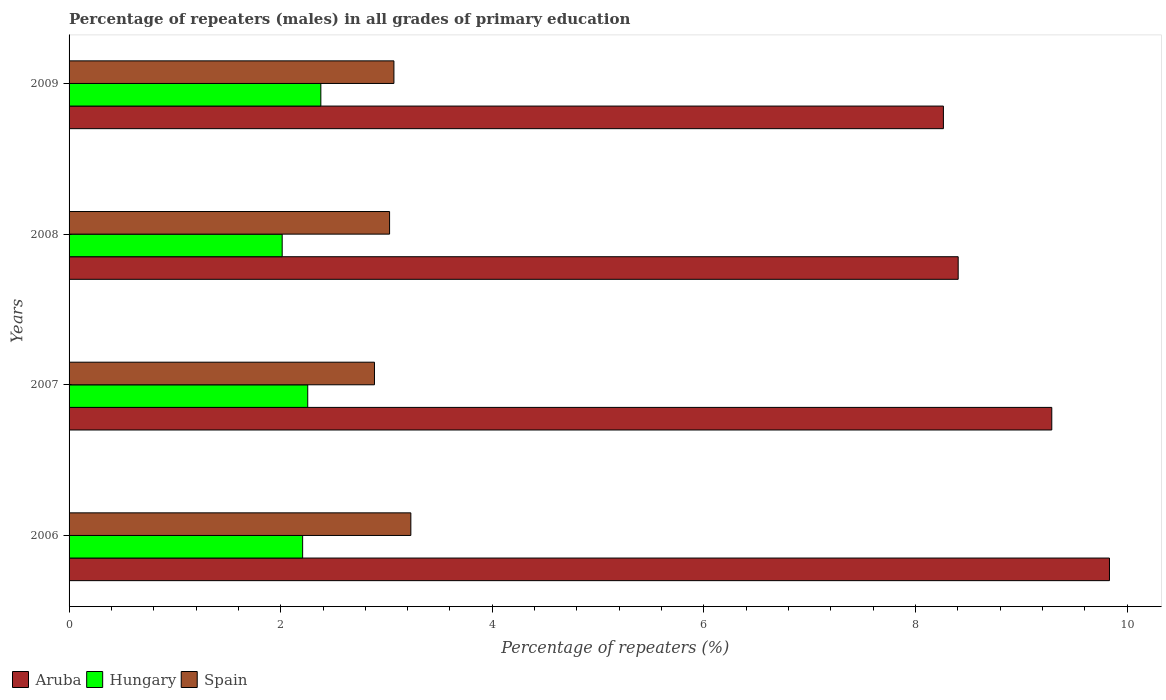How many different coloured bars are there?
Your answer should be compact. 3. How many groups of bars are there?
Make the answer very short. 4. Are the number of bars on each tick of the Y-axis equal?
Make the answer very short. Yes. How many bars are there on the 3rd tick from the top?
Ensure brevity in your answer.  3. In how many cases, is the number of bars for a given year not equal to the number of legend labels?
Offer a very short reply. 0. What is the percentage of repeaters (males) in Aruba in 2006?
Ensure brevity in your answer.  9.83. Across all years, what is the maximum percentage of repeaters (males) in Aruba?
Ensure brevity in your answer.  9.83. Across all years, what is the minimum percentage of repeaters (males) in Hungary?
Provide a succinct answer. 2.01. In which year was the percentage of repeaters (males) in Aruba minimum?
Ensure brevity in your answer.  2009. What is the total percentage of repeaters (males) in Aruba in the graph?
Give a very brief answer. 35.79. What is the difference between the percentage of repeaters (males) in Spain in 2008 and that in 2009?
Make the answer very short. -0.04. What is the difference between the percentage of repeaters (males) in Spain in 2009 and the percentage of repeaters (males) in Hungary in 2008?
Your response must be concise. 1.06. What is the average percentage of repeaters (males) in Hungary per year?
Provide a succinct answer. 2.21. In the year 2008, what is the difference between the percentage of repeaters (males) in Aruba and percentage of repeaters (males) in Hungary?
Give a very brief answer. 6.39. What is the ratio of the percentage of repeaters (males) in Hungary in 2008 to that in 2009?
Your response must be concise. 0.85. Is the percentage of repeaters (males) in Spain in 2006 less than that in 2008?
Offer a very short reply. No. Is the difference between the percentage of repeaters (males) in Aruba in 2008 and 2009 greater than the difference between the percentage of repeaters (males) in Hungary in 2008 and 2009?
Give a very brief answer. Yes. What is the difference between the highest and the second highest percentage of repeaters (males) in Aruba?
Provide a short and direct response. 0.55. What is the difference between the highest and the lowest percentage of repeaters (males) in Hungary?
Provide a succinct answer. 0.37. What does the 2nd bar from the top in 2008 represents?
Offer a very short reply. Hungary. What does the 3rd bar from the bottom in 2009 represents?
Your answer should be very brief. Spain. Is it the case that in every year, the sum of the percentage of repeaters (males) in Aruba and percentage of repeaters (males) in Hungary is greater than the percentage of repeaters (males) in Spain?
Offer a terse response. Yes. How many years are there in the graph?
Provide a short and direct response. 4. Does the graph contain any zero values?
Ensure brevity in your answer.  No. How many legend labels are there?
Provide a short and direct response. 3. What is the title of the graph?
Your answer should be compact. Percentage of repeaters (males) in all grades of primary education. Does "India" appear as one of the legend labels in the graph?
Keep it short and to the point. No. What is the label or title of the X-axis?
Your response must be concise. Percentage of repeaters (%). What is the label or title of the Y-axis?
Offer a very short reply. Years. What is the Percentage of repeaters (%) of Aruba in 2006?
Make the answer very short. 9.83. What is the Percentage of repeaters (%) of Hungary in 2006?
Offer a very short reply. 2.21. What is the Percentage of repeaters (%) in Spain in 2006?
Ensure brevity in your answer.  3.23. What is the Percentage of repeaters (%) of Aruba in 2007?
Offer a very short reply. 9.29. What is the Percentage of repeaters (%) of Hungary in 2007?
Your answer should be very brief. 2.26. What is the Percentage of repeaters (%) in Spain in 2007?
Your response must be concise. 2.89. What is the Percentage of repeaters (%) in Aruba in 2008?
Offer a terse response. 8.4. What is the Percentage of repeaters (%) in Hungary in 2008?
Provide a short and direct response. 2.01. What is the Percentage of repeaters (%) of Spain in 2008?
Offer a very short reply. 3.03. What is the Percentage of repeaters (%) of Aruba in 2009?
Your answer should be compact. 8.26. What is the Percentage of repeaters (%) in Hungary in 2009?
Ensure brevity in your answer.  2.38. What is the Percentage of repeaters (%) in Spain in 2009?
Your response must be concise. 3.07. Across all years, what is the maximum Percentage of repeaters (%) of Aruba?
Make the answer very short. 9.83. Across all years, what is the maximum Percentage of repeaters (%) of Hungary?
Your answer should be very brief. 2.38. Across all years, what is the maximum Percentage of repeaters (%) in Spain?
Your answer should be compact. 3.23. Across all years, what is the minimum Percentage of repeaters (%) in Aruba?
Ensure brevity in your answer.  8.26. Across all years, what is the minimum Percentage of repeaters (%) of Hungary?
Offer a terse response. 2.01. Across all years, what is the minimum Percentage of repeaters (%) in Spain?
Keep it short and to the point. 2.89. What is the total Percentage of repeaters (%) of Aruba in the graph?
Make the answer very short. 35.79. What is the total Percentage of repeaters (%) of Hungary in the graph?
Offer a terse response. 8.86. What is the total Percentage of repeaters (%) in Spain in the graph?
Provide a short and direct response. 12.22. What is the difference between the Percentage of repeaters (%) of Aruba in 2006 and that in 2007?
Your answer should be very brief. 0.55. What is the difference between the Percentage of repeaters (%) in Hungary in 2006 and that in 2007?
Offer a terse response. -0.05. What is the difference between the Percentage of repeaters (%) of Spain in 2006 and that in 2007?
Give a very brief answer. 0.34. What is the difference between the Percentage of repeaters (%) in Aruba in 2006 and that in 2008?
Keep it short and to the point. 1.43. What is the difference between the Percentage of repeaters (%) of Hungary in 2006 and that in 2008?
Give a very brief answer. 0.19. What is the difference between the Percentage of repeaters (%) in Spain in 2006 and that in 2008?
Offer a very short reply. 0.2. What is the difference between the Percentage of repeaters (%) of Aruba in 2006 and that in 2009?
Provide a short and direct response. 1.57. What is the difference between the Percentage of repeaters (%) in Hungary in 2006 and that in 2009?
Provide a succinct answer. -0.17. What is the difference between the Percentage of repeaters (%) in Spain in 2006 and that in 2009?
Your answer should be compact. 0.16. What is the difference between the Percentage of repeaters (%) of Aruba in 2007 and that in 2008?
Offer a very short reply. 0.88. What is the difference between the Percentage of repeaters (%) of Hungary in 2007 and that in 2008?
Provide a succinct answer. 0.24. What is the difference between the Percentage of repeaters (%) in Spain in 2007 and that in 2008?
Provide a succinct answer. -0.14. What is the difference between the Percentage of repeaters (%) of Aruba in 2007 and that in 2009?
Your answer should be compact. 1.02. What is the difference between the Percentage of repeaters (%) of Hungary in 2007 and that in 2009?
Provide a succinct answer. -0.12. What is the difference between the Percentage of repeaters (%) in Spain in 2007 and that in 2009?
Offer a very short reply. -0.18. What is the difference between the Percentage of repeaters (%) of Aruba in 2008 and that in 2009?
Offer a terse response. 0.14. What is the difference between the Percentage of repeaters (%) of Hungary in 2008 and that in 2009?
Your answer should be compact. -0.37. What is the difference between the Percentage of repeaters (%) in Spain in 2008 and that in 2009?
Provide a succinct answer. -0.04. What is the difference between the Percentage of repeaters (%) of Aruba in 2006 and the Percentage of repeaters (%) of Hungary in 2007?
Your answer should be compact. 7.58. What is the difference between the Percentage of repeaters (%) in Aruba in 2006 and the Percentage of repeaters (%) in Spain in 2007?
Your response must be concise. 6.95. What is the difference between the Percentage of repeaters (%) in Hungary in 2006 and the Percentage of repeaters (%) in Spain in 2007?
Offer a very short reply. -0.68. What is the difference between the Percentage of repeaters (%) of Aruba in 2006 and the Percentage of repeaters (%) of Hungary in 2008?
Your response must be concise. 7.82. What is the difference between the Percentage of repeaters (%) of Aruba in 2006 and the Percentage of repeaters (%) of Spain in 2008?
Provide a succinct answer. 6.8. What is the difference between the Percentage of repeaters (%) of Hungary in 2006 and the Percentage of repeaters (%) of Spain in 2008?
Give a very brief answer. -0.82. What is the difference between the Percentage of repeaters (%) of Aruba in 2006 and the Percentage of repeaters (%) of Hungary in 2009?
Your response must be concise. 7.45. What is the difference between the Percentage of repeaters (%) in Aruba in 2006 and the Percentage of repeaters (%) in Spain in 2009?
Provide a succinct answer. 6.76. What is the difference between the Percentage of repeaters (%) of Hungary in 2006 and the Percentage of repeaters (%) of Spain in 2009?
Your response must be concise. -0.86. What is the difference between the Percentage of repeaters (%) of Aruba in 2007 and the Percentage of repeaters (%) of Hungary in 2008?
Provide a succinct answer. 7.27. What is the difference between the Percentage of repeaters (%) in Aruba in 2007 and the Percentage of repeaters (%) in Spain in 2008?
Provide a short and direct response. 6.26. What is the difference between the Percentage of repeaters (%) in Hungary in 2007 and the Percentage of repeaters (%) in Spain in 2008?
Ensure brevity in your answer.  -0.77. What is the difference between the Percentage of repeaters (%) in Aruba in 2007 and the Percentage of repeaters (%) in Hungary in 2009?
Keep it short and to the point. 6.91. What is the difference between the Percentage of repeaters (%) in Aruba in 2007 and the Percentage of repeaters (%) in Spain in 2009?
Provide a short and direct response. 6.22. What is the difference between the Percentage of repeaters (%) of Hungary in 2007 and the Percentage of repeaters (%) of Spain in 2009?
Offer a terse response. -0.81. What is the difference between the Percentage of repeaters (%) in Aruba in 2008 and the Percentage of repeaters (%) in Hungary in 2009?
Offer a terse response. 6.02. What is the difference between the Percentage of repeaters (%) in Aruba in 2008 and the Percentage of repeaters (%) in Spain in 2009?
Offer a very short reply. 5.33. What is the difference between the Percentage of repeaters (%) of Hungary in 2008 and the Percentage of repeaters (%) of Spain in 2009?
Your response must be concise. -1.06. What is the average Percentage of repeaters (%) in Aruba per year?
Your response must be concise. 8.95. What is the average Percentage of repeaters (%) in Hungary per year?
Ensure brevity in your answer.  2.21. What is the average Percentage of repeaters (%) of Spain per year?
Offer a terse response. 3.05. In the year 2006, what is the difference between the Percentage of repeaters (%) of Aruba and Percentage of repeaters (%) of Hungary?
Your answer should be very brief. 7.63. In the year 2006, what is the difference between the Percentage of repeaters (%) of Aruba and Percentage of repeaters (%) of Spain?
Provide a succinct answer. 6.6. In the year 2006, what is the difference between the Percentage of repeaters (%) in Hungary and Percentage of repeaters (%) in Spain?
Make the answer very short. -1.02. In the year 2007, what is the difference between the Percentage of repeaters (%) of Aruba and Percentage of repeaters (%) of Hungary?
Your response must be concise. 7.03. In the year 2007, what is the difference between the Percentage of repeaters (%) of Aruba and Percentage of repeaters (%) of Spain?
Your response must be concise. 6.4. In the year 2007, what is the difference between the Percentage of repeaters (%) in Hungary and Percentage of repeaters (%) in Spain?
Give a very brief answer. -0.63. In the year 2008, what is the difference between the Percentage of repeaters (%) of Aruba and Percentage of repeaters (%) of Hungary?
Ensure brevity in your answer.  6.39. In the year 2008, what is the difference between the Percentage of repeaters (%) of Aruba and Percentage of repeaters (%) of Spain?
Ensure brevity in your answer.  5.37. In the year 2008, what is the difference between the Percentage of repeaters (%) of Hungary and Percentage of repeaters (%) of Spain?
Your response must be concise. -1.01. In the year 2009, what is the difference between the Percentage of repeaters (%) in Aruba and Percentage of repeaters (%) in Hungary?
Provide a succinct answer. 5.88. In the year 2009, what is the difference between the Percentage of repeaters (%) in Aruba and Percentage of repeaters (%) in Spain?
Provide a short and direct response. 5.19. In the year 2009, what is the difference between the Percentage of repeaters (%) in Hungary and Percentage of repeaters (%) in Spain?
Offer a very short reply. -0.69. What is the ratio of the Percentage of repeaters (%) of Aruba in 2006 to that in 2007?
Make the answer very short. 1.06. What is the ratio of the Percentage of repeaters (%) of Hungary in 2006 to that in 2007?
Keep it short and to the point. 0.98. What is the ratio of the Percentage of repeaters (%) in Spain in 2006 to that in 2007?
Ensure brevity in your answer.  1.12. What is the ratio of the Percentage of repeaters (%) of Aruba in 2006 to that in 2008?
Your response must be concise. 1.17. What is the ratio of the Percentage of repeaters (%) of Hungary in 2006 to that in 2008?
Offer a very short reply. 1.1. What is the ratio of the Percentage of repeaters (%) of Spain in 2006 to that in 2008?
Your answer should be very brief. 1.07. What is the ratio of the Percentage of repeaters (%) in Aruba in 2006 to that in 2009?
Provide a short and direct response. 1.19. What is the ratio of the Percentage of repeaters (%) in Hungary in 2006 to that in 2009?
Your answer should be compact. 0.93. What is the ratio of the Percentage of repeaters (%) of Spain in 2006 to that in 2009?
Your answer should be very brief. 1.05. What is the ratio of the Percentage of repeaters (%) in Aruba in 2007 to that in 2008?
Ensure brevity in your answer.  1.11. What is the ratio of the Percentage of repeaters (%) of Hungary in 2007 to that in 2008?
Your answer should be compact. 1.12. What is the ratio of the Percentage of repeaters (%) in Spain in 2007 to that in 2008?
Your response must be concise. 0.95. What is the ratio of the Percentage of repeaters (%) in Aruba in 2007 to that in 2009?
Your answer should be compact. 1.12. What is the ratio of the Percentage of repeaters (%) of Hungary in 2007 to that in 2009?
Your answer should be compact. 0.95. What is the ratio of the Percentage of repeaters (%) in Spain in 2007 to that in 2009?
Provide a succinct answer. 0.94. What is the ratio of the Percentage of repeaters (%) in Aruba in 2008 to that in 2009?
Ensure brevity in your answer.  1.02. What is the ratio of the Percentage of repeaters (%) in Hungary in 2008 to that in 2009?
Provide a succinct answer. 0.85. What is the ratio of the Percentage of repeaters (%) in Spain in 2008 to that in 2009?
Keep it short and to the point. 0.99. What is the difference between the highest and the second highest Percentage of repeaters (%) of Aruba?
Ensure brevity in your answer.  0.55. What is the difference between the highest and the second highest Percentage of repeaters (%) of Hungary?
Ensure brevity in your answer.  0.12. What is the difference between the highest and the second highest Percentage of repeaters (%) in Spain?
Give a very brief answer. 0.16. What is the difference between the highest and the lowest Percentage of repeaters (%) of Aruba?
Offer a very short reply. 1.57. What is the difference between the highest and the lowest Percentage of repeaters (%) in Hungary?
Your answer should be very brief. 0.37. What is the difference between the highest and the lowest Percentage of repeaters (%) of Spain?
Make the answer very short. 0.34. 